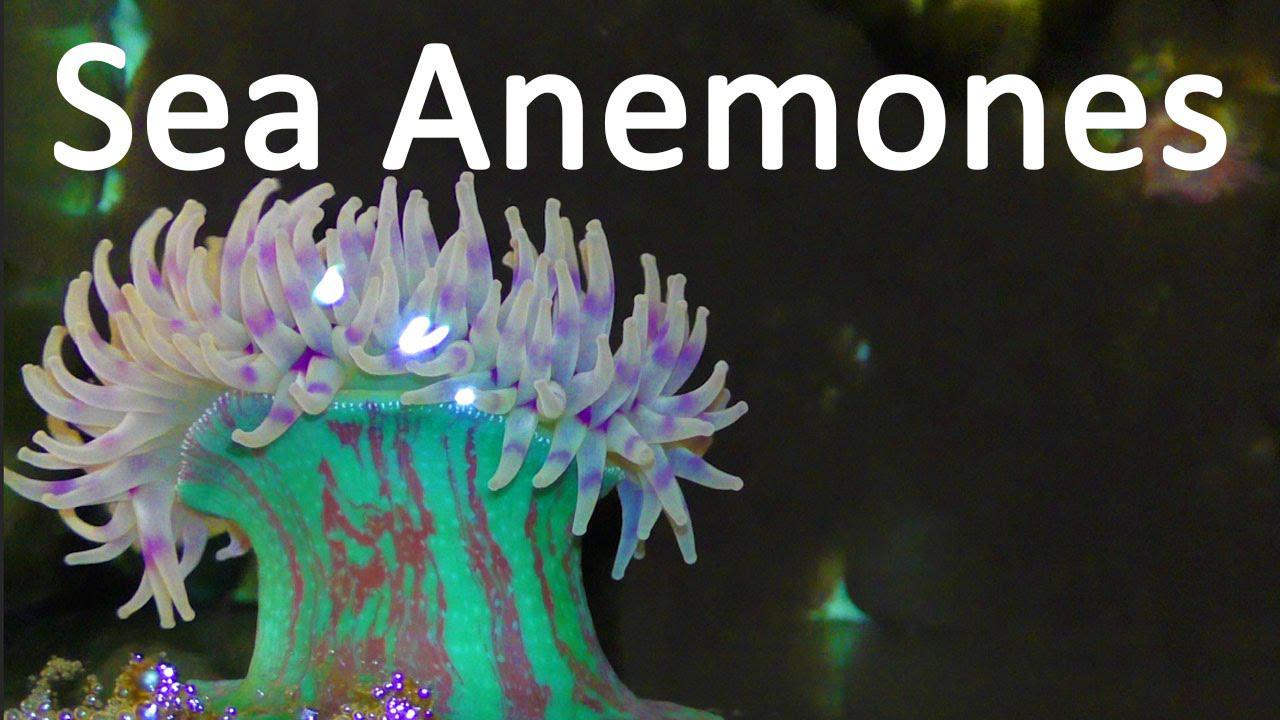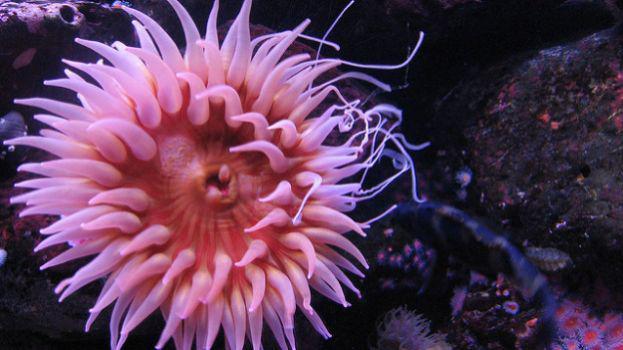The first image is the image on the left, the second image is the image on the right. Considering the images on both sides, is "The colors of the anemones are soft greens and blues." valid? Answer yes or no. No. 